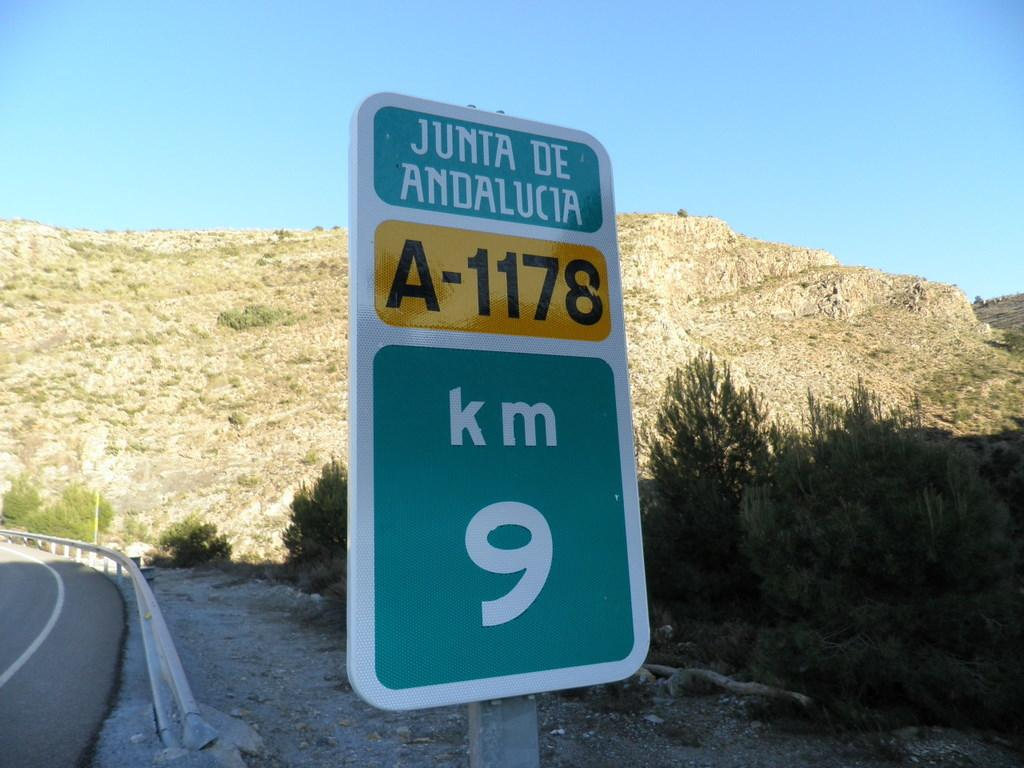<image>
Provide a brief description of the given image. A 9 Km road sign for Junta De Andalucia. 